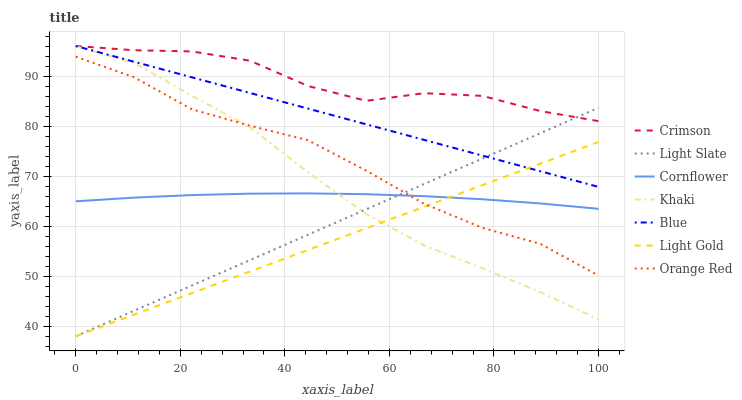Does Light Gold have the minimum area under the curve?
Answer yes or no. Yes. Does Crimson have the maximum area under the curve?
Answer yes or no. Yes. Does Cornflower have the minimum area under the curve?
Answer yes or no. No. Does Cornflower have the maximum area under the curve?
Answer yes or no. No. Is Light Gold the smoothest?
Answer yes or no. Yes. Is Crimson the roughest?
Answer yes or no. Yes. Is Cornflower the smoothest?
Answer yes or no. No. Is Cornflower the roughest?
Answer yes or no. No. Does Light Slate have the lowest value?
Answer yes or no. Yes. Does Cornflower have the lowest value?
Answer yes or no. No. Does Crimson have the highest value?
Answer yes or no. Yes. Does Khaki have the highest value?
Answer yes or no. No. Is Orange Red less than Blue?
Answer yes or no. Yes. Is Blue greater than Orange Red?
Answer yes or no. Yes. Does Orange Red intersect Light Slate?
Answer yes or no. Yes. Is Orange Red less than Light Slate?
Answer yes or no. No. Is Orange Red greater than Light Slate?
Answer yes or no. No. Does Orange Red intersect Blue?
Answer yes or no. No. 